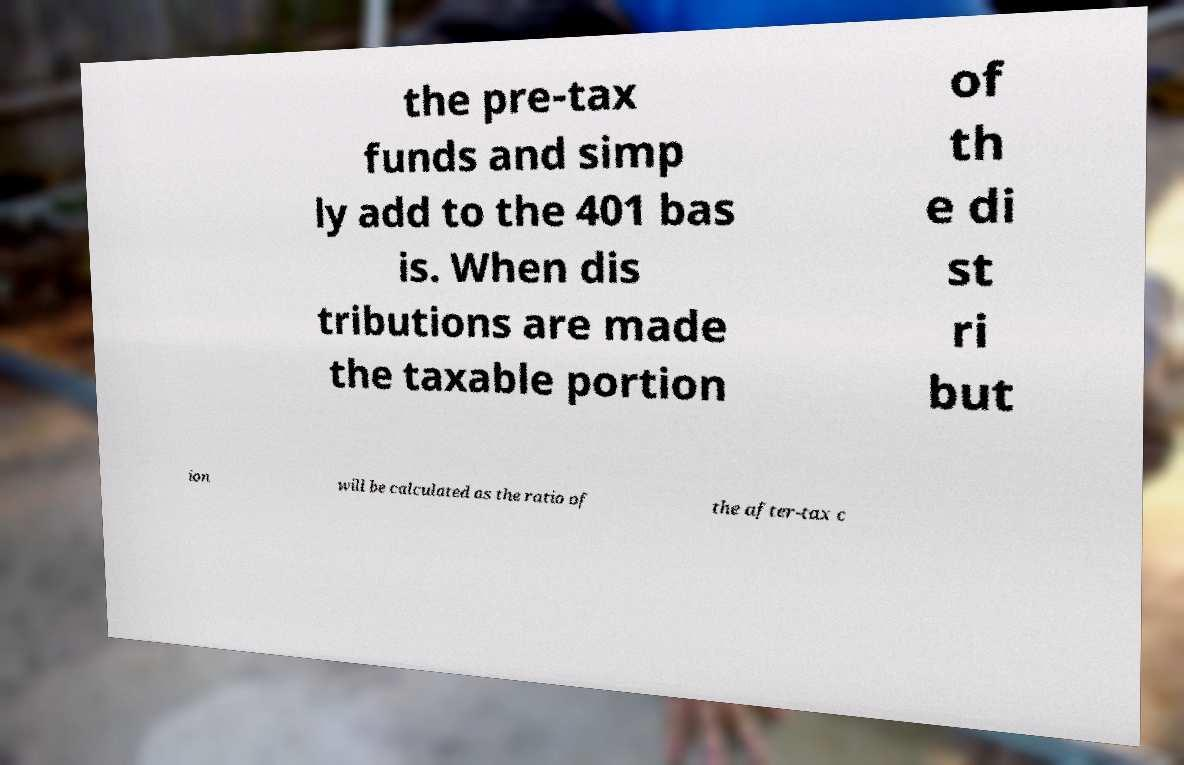I need the written content from this picture converted into text. Can you do that? the pre-tax funds and simp ly add to the 401 bas is. When dis tributions are made the taxable portion of th e di st ri but ion will be calculated as the ratio of the after-tax c 